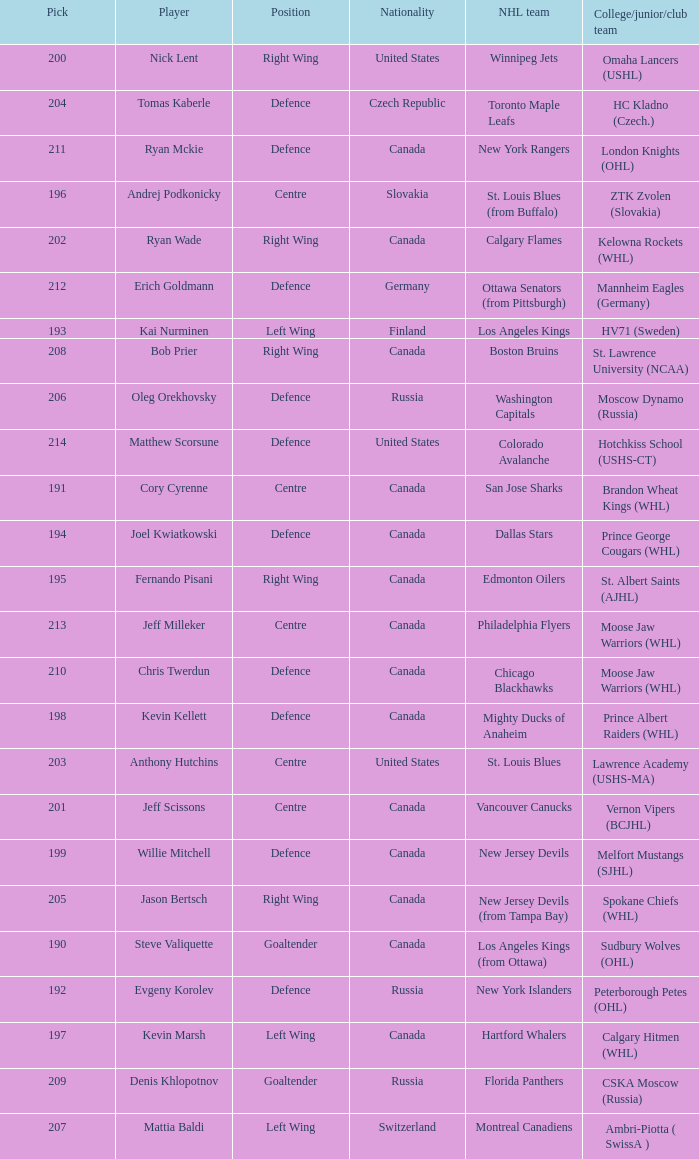Name the pick for matthew scorsune 214.0. 